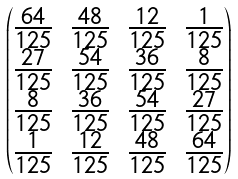Convert formula to latex. <formula><loc_0><loc_0><loc_500><loc_500>\begin{pmatrix} \frac { 6 4 } { 1 2 5 } & \frac { 4 8 } { 1 2 5 } & \frac { 1 2 } { 1 2 5 } & \frac { 1 } { 1 2 5 } \\ \frac { 2 7 } { 1 2 5 } & \frac { 5 4 } { 1 2 5 } & \frac { 3 6 } { 1 2 5 } & \frac { 8 } { 1 2 5 } \\ \frac { 8 } { 1 2 5 } & \frac { 3 6 } { 1 2 5 } & \frac { 5 4 } { 1 2 5 } & \frac { 2 7 } { 1 2 5 } \\ \frac { 1 } { 1 2 5 } & \frac { 1 2 } { 1 2 5 } & \frac { 4 8 } { 1 2 5 } & \frac { 6 4 } { 1 2 5 } \end{pmatrix}</formula> 